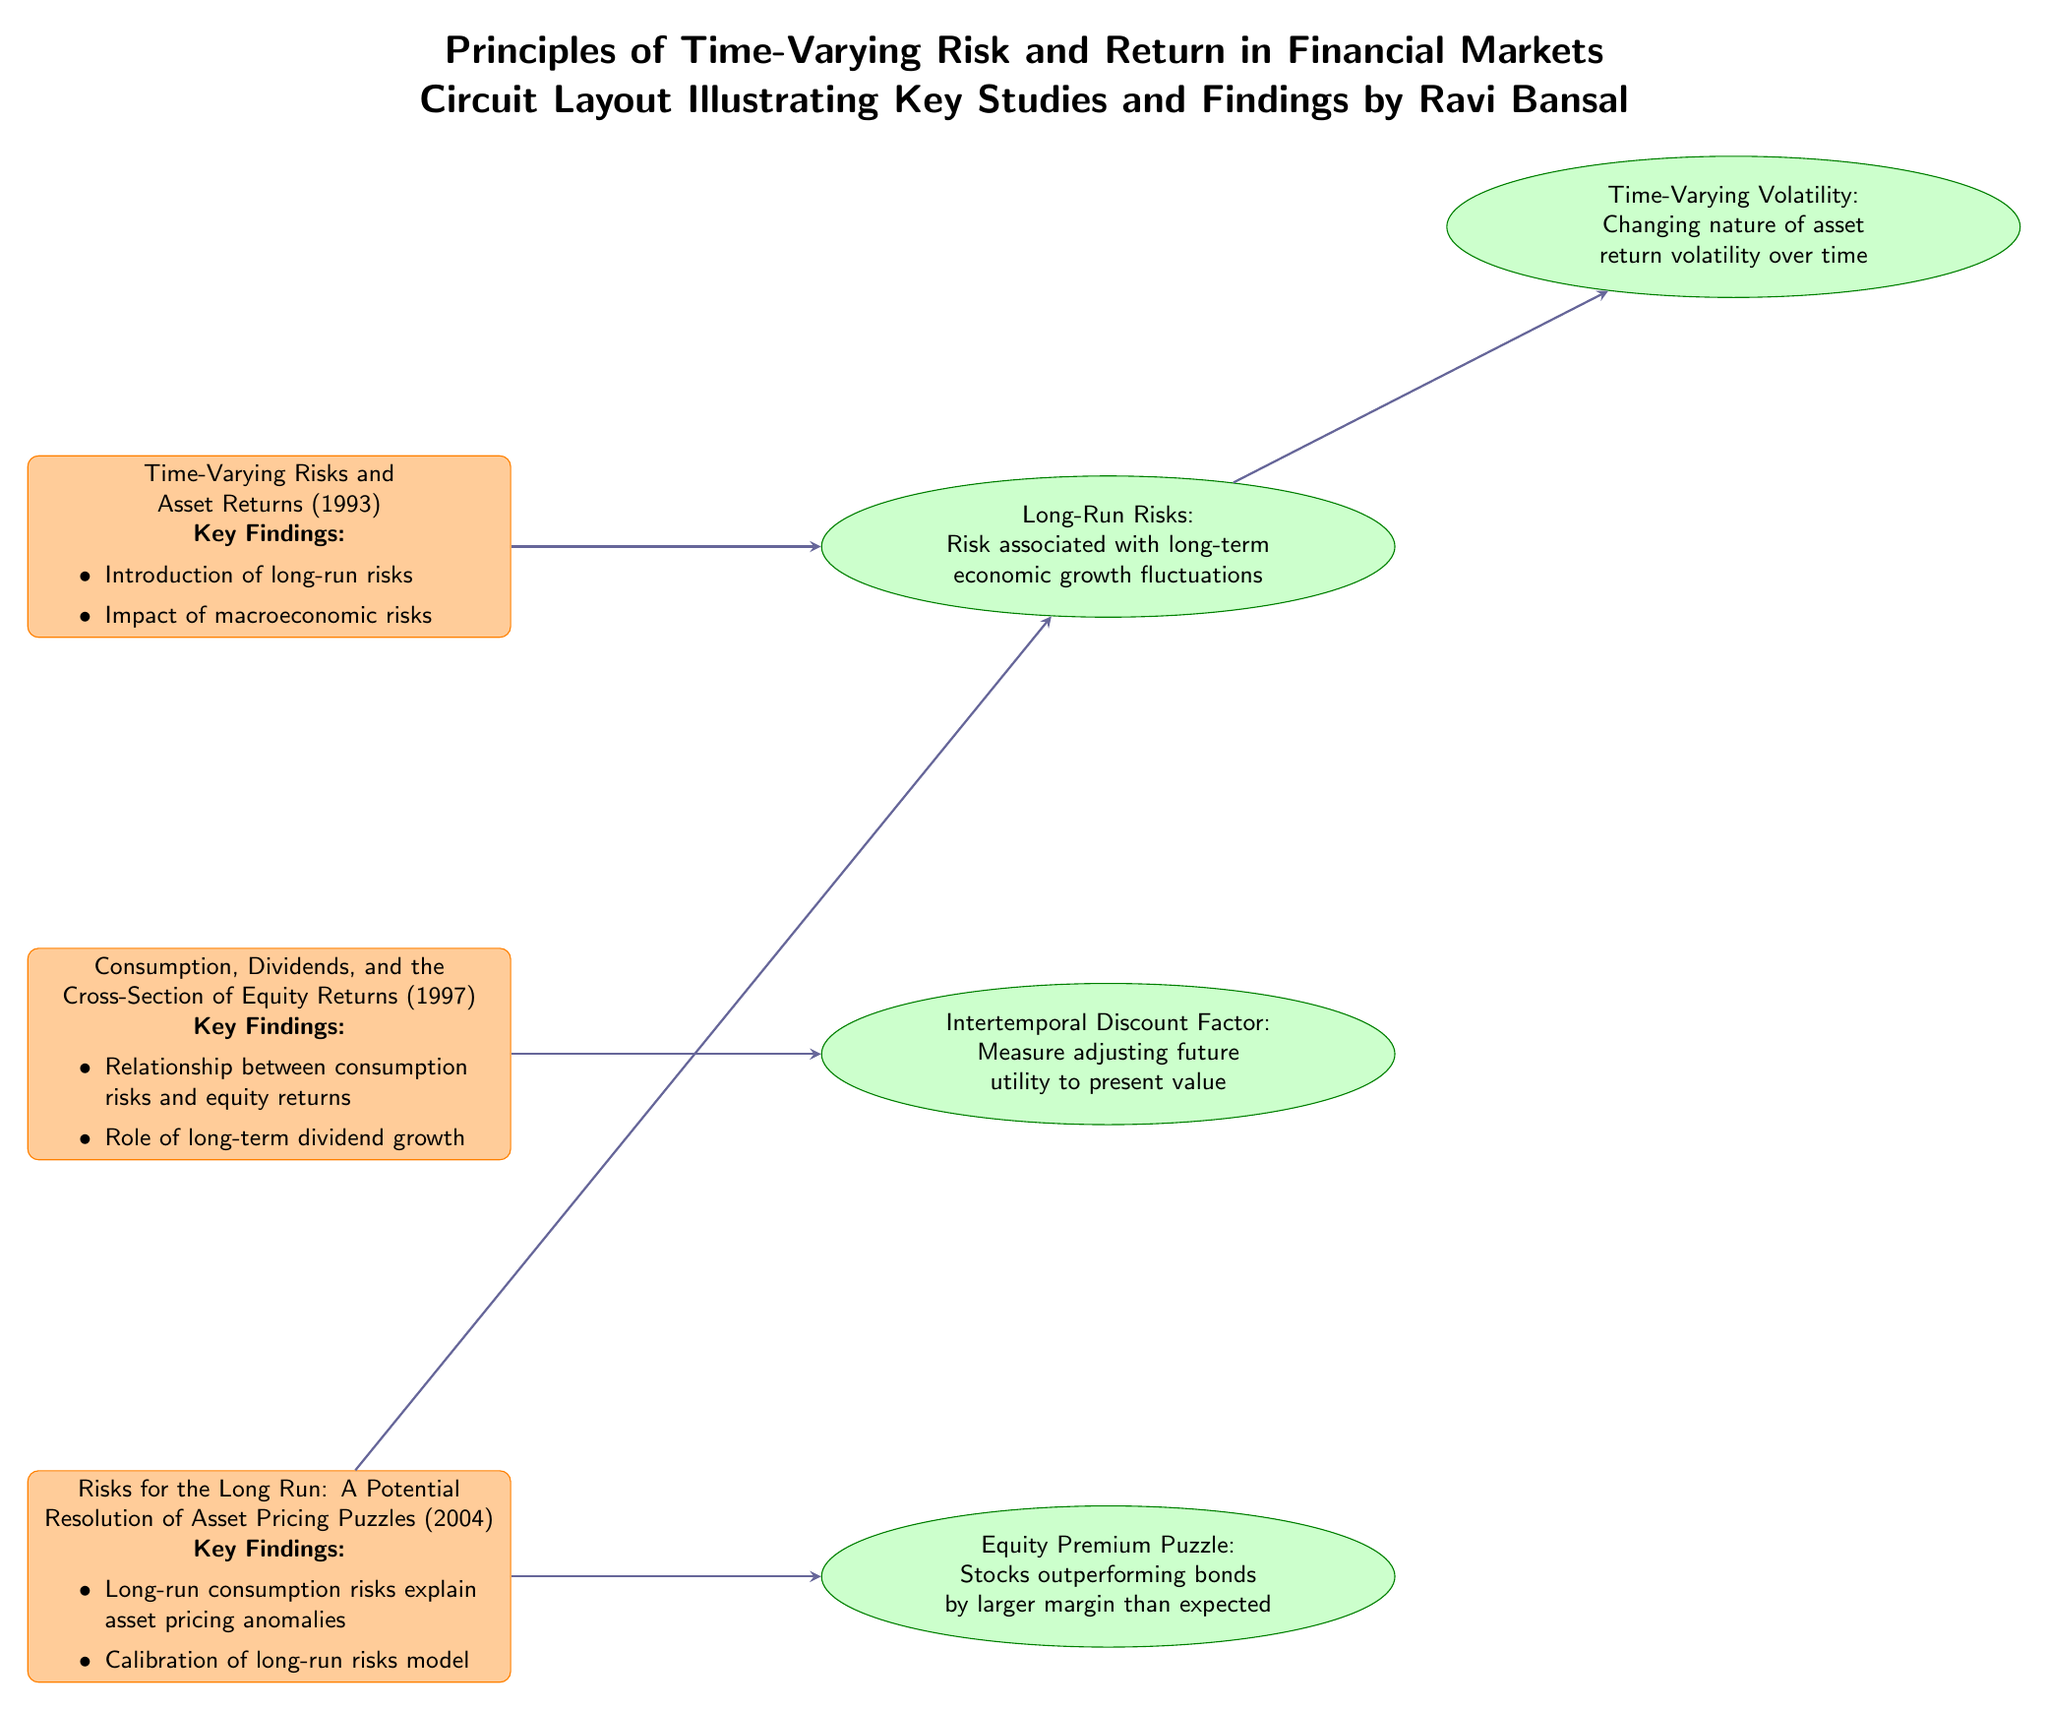What are the three key studies referenced in the diagram? The diagram lists three studies: "Time-Varying Risks and Asset Returns (1993)", "Consumption, Dividends, and the Cross-Section of Equity Returns (1997)", and "Risks for the Long Run: A Potential Resolution of Asset Pricing Puzzles (2004)".
Answer: Time-Varying Risks and Asset Returns, Consumption, Dividends, and the Cross-Section of Equity Returns, Risks for the Long Run Which study discusses the relationship between consumption risks and equity returns? The second study listed in the diagram is "Consumption, Dividends, and the Cross-Section of Equity Returns (1997)", which explicitly mentions the relationship between consumption risks and equity returns.
Answer: Consumption, Dividends, and the Cross-Section of Equity Returns What concept is associated with the study "Time-Varying Risks and Asset Returns"? The concept linked to the study "Time-Varying Risks and Asset Returns" is "Long-Run Risks". The arrow connecting the two nodes indicates this direct relationship.
Answer: Long-Run Risks Which concept explains why stocks outperform bonds more than expected, as stated in the diagram? The concept that explains the phenomenon of stocks outperforming bonds by a larger margin than anticipated is the "Equity Premium Puzzle", which is connected to the study that addresses long-run risks.
Answer: Equity Premium Puzzle How many arrows connect the study "Risks for the Long Run" to concepts? There are two arrows connecting "Risks for the Long Run: A Potential Resolution of Asset Pricing Puzzles" to different concepts: one to "Equity Premium Puzzle" and another to "Long-Run Risks".
Answer: 2 Which concept has a direct connection to "Long-Run Risks"? The diagram shows that "Long-Run Risks" has a direct connection to the concept "Time-Varying Volatility" through an arrow.
Answer: Time-Varying Volatility What is the main theme addressed in the studies displayed in the circuit? The main theme explored in these studies is "time-varying risk and return in financial markets", as suggested by the title of the circuit layout.
Answer: Time-varying risk and return in financial markets List the year when the study titled "Consumption, Dividends, and the Cross-Section of Equity Returns" was published. The year of publication for the study "Consumption, Dividends, and the Cross-Section of Equity Returns" is 1997, which is indicated next to the study's title in the diagram.
Answer: 1997 What are the two concepts that connect to "Risks for the Long Run"? The diagram shows "Risks for the Long Run" is connected to both "Equity Premium Puzzle" and "Long-Run Risks", indicating their relationships.
Answer: Equity Premium Puzzle, Long-Run Risks 